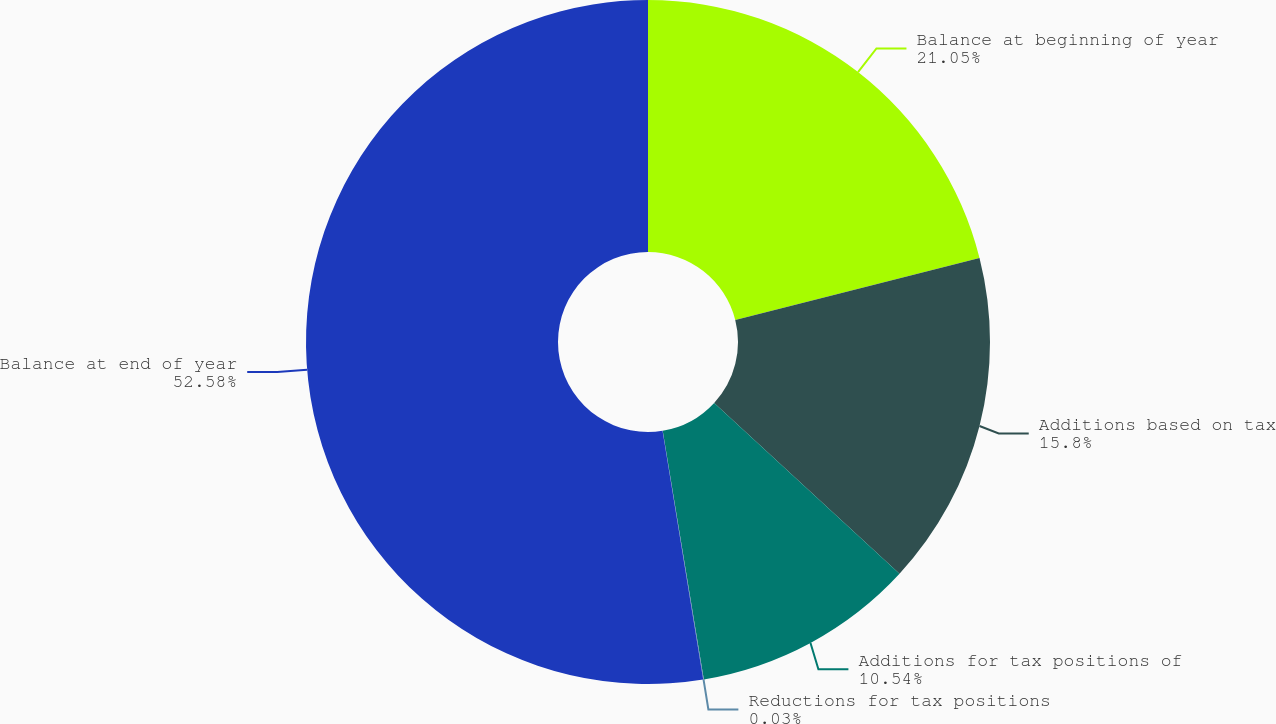Convert chart to OTSL. <chart><loc_0><loc_0><loc_500><loc_500><pie_chart><fcel>Balance at beginning of year<fcel>Additions based on tax<fcel>Additions for tax positions of<fcel>Reductions for tax positions<fcel>Balance at end of year<nl><fcel>21.05%<fcel>15.8%<fcel>10.54%<fcel>0.03%<fcel>52.58%<nl></chart> 